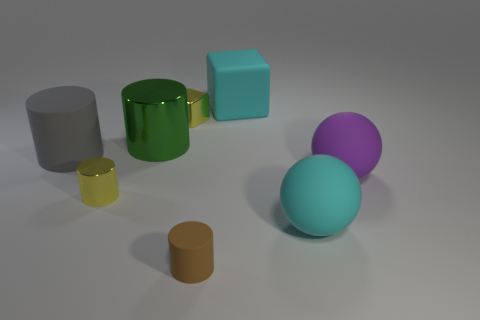There is a object that is the same color as the matte block; what shape is it?
Your answer should be compact. Sphere. Is the tiny metallic block the same color as the tiny shiny cylinder?
Your response must be concise. Yes. Is the number of big cyan matte things on the left side of the metallic block the same as the number of blue shiny spheres?
Offer a very short reply. Yes. There is a brown cylinder that is in front of the green thing; is its size the same as the purple rubber object?
Offer a terse response. No. How many big green cylinders are on the left side of the yellow cube?
Your response must be concise. 1. There is a big thing that is both in front of the big cyan block and behind the large gray thing; what is its material?
Your response must be concise. Metal. How many small things are purple shiny things or rubber things?
Your answer should be compact. 1. The cyan cube has what size?
Your answer should be compact. Large. The large purple rubber object has what shape?
Provide a short and direct response. Sphere. Is there anything else that has the same shape as the large gray thing?
Provide a short and direct response. Yes. 